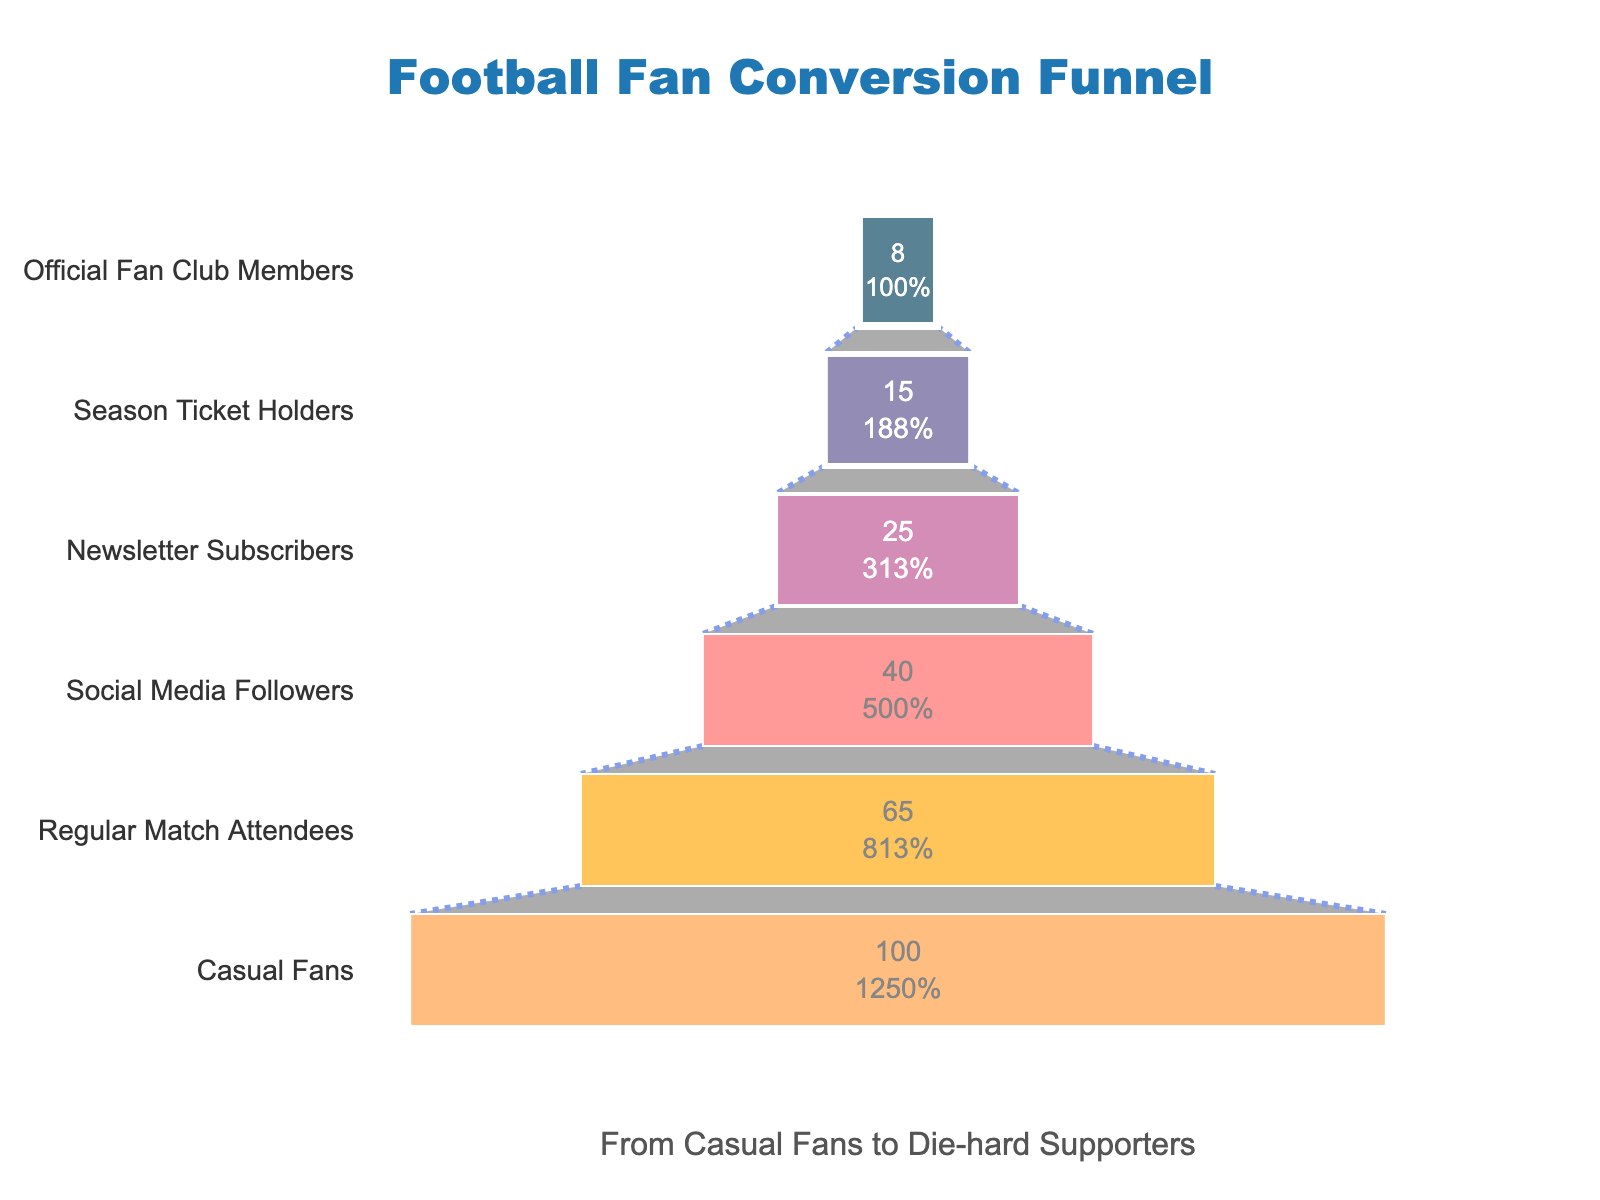What is the percentage of season ticket holders? The label for the 'Season Ticket Holders' stage shows that the percentage of fans who become season ticket holders is 15%.
Answer: 15% What is the title of the funnel chart? The title is displayed at the top center of the chart and reads, "Football Fan Conversion Funnel."
Answer: Football Fan Conversion Funnel Which stage has the highest percentage conversion rate? The highest percentage is at the top of the funnel, represented by 'Casual Fans' with 100%.
Answer: Casual Fans How many stages are shown in the funnel chart? Counting the distinct stages listed from top to bottom yields a total of 6 stages.
Answer: 6 What percentage of casual fans become newsletter subscribers? The percentage of 'Newsletter Subscribers' is 25%. Since this is directly derived from 'Casual Fans', the conversion rate from casual fans to newsletter subscribers is 25%.
Answer: 25% By how many percentage points do regular match attendees differ from social media followers? The percentage for 'Regular Match Attendees' is 65% and 'Social Media Followers' is 40%. The difference is 65% - 40% = 25%.
Answer: 25% Which stage experiences the highest drop in percentage from the previous stage? By examining the differences: from 'Casual Fans' (100%) to 'Regular Match Attendees' (65%), the drop is 35%; from 'Regular Match Attendees' (65%) to 'Social Media Followers' (40%), the drop is 25%; from 'Social Media Followers' (40%) to 'Newsletter Subscribers' (25%), the drop is 15%; from 'Newsletter Subscribers' (25%) to 'Season Ticket Holders' (15%), the drop is 10%; and from 'Season Ticket Holders' (15%) to 'Official Fan Club Members' (8%), the drop is 7%. The widest gap is from 'Casual Fans' to 'Regular Match Attendees' with 35%.
Answer: Casual Fans to Regular Match Attendees What color is used to represent the 'Official Fan Club Members' stage? The 'Official Fan Club Members' stage, located at the bottom of the funnel, is represented with a light brownish color.
Answer: Light brownish Calculate the average percentage of all the stages listed in the chart. Summing all the percentages: 100% + 65% + 40% + 25% + 15% + 8% = 253%. Dividing by the number of stages (6), the average is 253/6 ≈ 42.17%.
Answer: 42.17% Identify the second most converted stage from casual fans. The second highest percentage is 'Regular Match Attendees' with 65%, which means it is the stage second most converted from 'Casual Fans' following 'Official Fan Club Members'.
Answer: Regular Match Attendees 